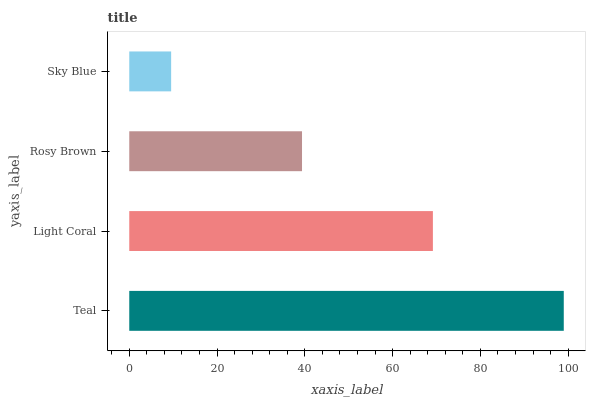Is Sky Blue the minimum?
Answer yes or no. Yes. Is Teal the maximum?
Answer yes or no. Yes. Is Light Coral the minimum?
Answer yes or no. No. Is Light Coral the maximum?
Answer yes or no. No. Is Teal greater than Light Coral?
Answer yes or no. Yes. Is Light Coral less than Teal?
Answer yes or no. Yes. Is Light Coral greater than Teal?
Answer yes or no. No. Is Teal less than Light Coral?
Answer yes or no. No. Is Light Coral the high median?
Answer yes or no. Yes. Is Rosy Brown the low median?
Answer yes or no. Yes. Is Rosy Brown the high median?
Answer yes or no. No. Is Sky Blue the low median?
Answer yes or no. No. 